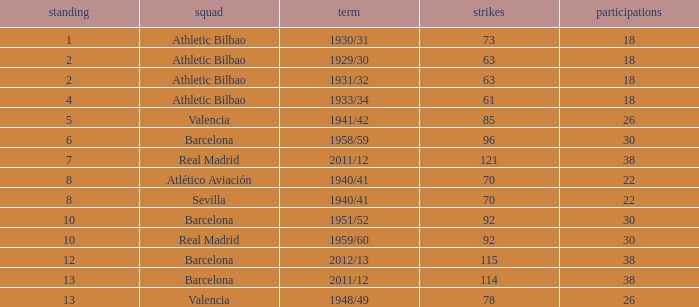What are the apps for less than 61 goals and before rank 6? None. 